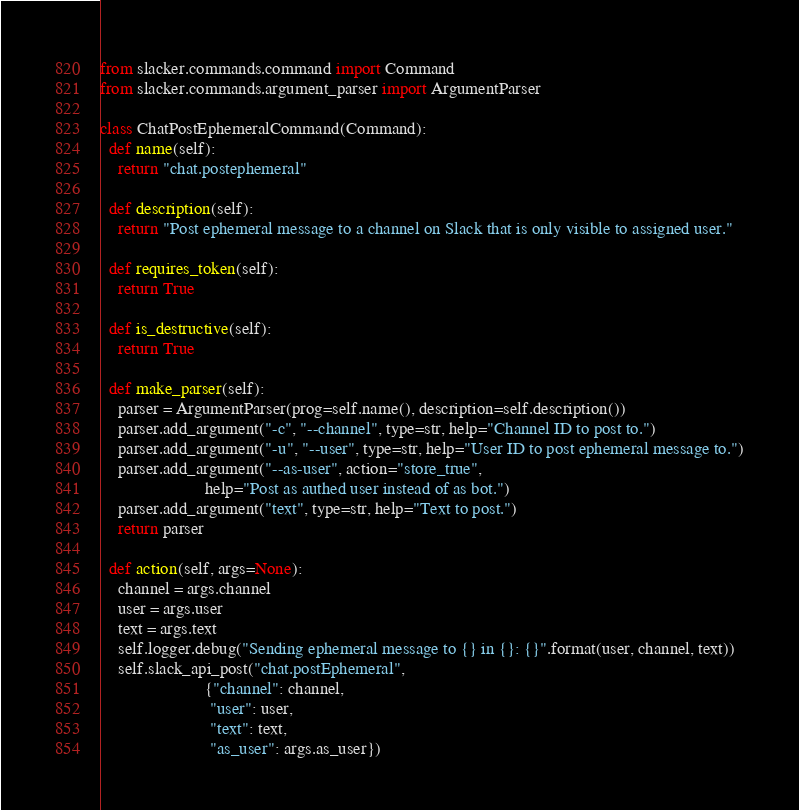Convert code to text. <code><loc_0><loc_0><loc_500><loc_500><_Python_>from slacker.commands.command import Command
from slacker.commands.argument_parser import ArgumentParser

class ChatPostEphemeralCommand(Command):
  def name(self):
    return "chat.postephemeral"

  def description(self):
    return "Post ephemeral message to a channel on Slack that is only visible to assigned user."

  def requires_token(self):
    return True

  def is_destructive(self):
    return True

  def make_parser(self):
    parser = ArgumentParser(prog=self.name(), description=self.description())
    parser.add_argument("-c", "--channel", type=str, help="Channel ID to post to.")
    parser.add_argument("-u", "--user", type=str, help="User ID to post ephemeral message to.")
    parser.add_argument("--as-user", action="store_true",
                        help="Post as authed user instead of as bot.")
    parser.add_argument("text", type=str, help="Text to post.")
    return parser

  def action(self, args=None):
    channel = args.channel
    user = args.user
    text = args.text
    self.logger.debug("Sending ephemeral message to {} in {}: {}".format(user, channel, text))
    self.slack_api_post("chat.postEphemeral",
                        {"channel": channel,
                         "user": user,
                         "text": text,
                         "as_user": args.as_user})
</code> 